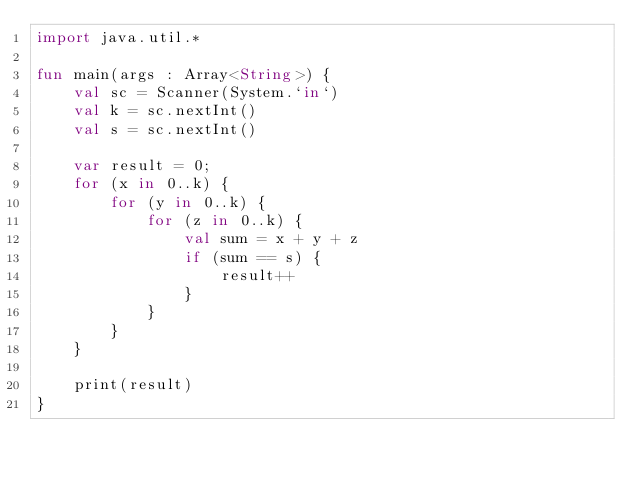<code> <loc_0><loc_0><loc_500><loc_500><_Kotlin_>import java.util.*

fun main(args : Array<String>) {
    val sc = Scanner(System.`in`)
    val k = sc.nextInt()
    val s = sc.nextInt()

    var result = 0;
    for (x in 0..k) {
        for (y in 0..k) {
            for (z in 0..k) {
                val sum = x + y + z
                if (sum == s) {
                    result++
                }
            }
        }
    }

    print(result)
}</code> 